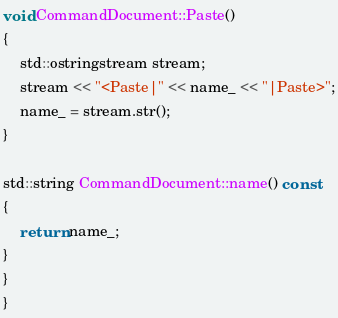Convert code to text. <code><loc_0><loc_0><loc_500><loc_500><_C++_>
void CommandDocument::Paste()
{
	std::ostringstream stream;
	stream << "<Paste|" << name_ << "|Paste>";
	name_ = stream.str();
}

std::string CommandDocument::name() const
{
	return name_;
}
}
}

</code> 